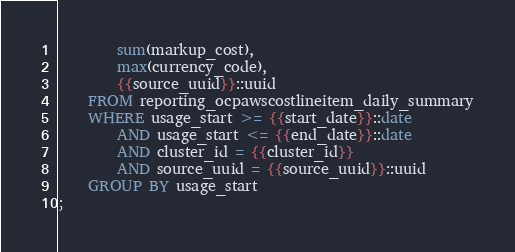Convert code to text. <code><loc_0><loc_0><loc_500><loc_500><_SQL_>        sum(markup_cost),
        max(currency_code),
        {{source_uuid}}::uuid
    FROM reporting_ocpawscostlineitem_daily_summary
    WHERE usage_start >= {{start_date}}::date
        AND usage_start <= {{end_date}}::date
        AND cluster_id = {{cluster_id}}
        AND source_uuid = {{source_uuid}}::uuid
    GROUP BY usage_start
;
</code> 